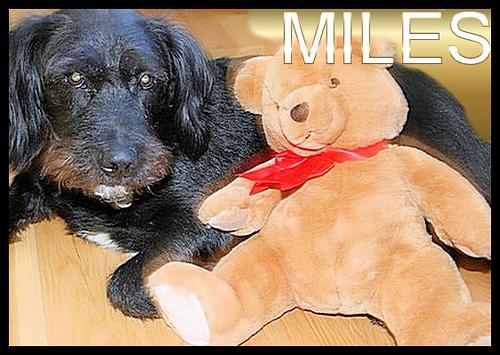What color is the bear's ribbon?
Be succinct. Red. What type of dog is this?
Write a very short answer. Terrier. Is the dog playing with stuffed animals?
Short answer required. Yes. What sport does this dog play?
Be succinct. None. What color are the dogs eyes?
Keep it brief. Brown. Does the dog look happy?
Concise answer only. No. Does the dog want to play?
Quick response, please. No. What do you think the dog's name is?
Keep it brief. Miles. What breed of dog is this?
Short answer required. Schnauzer. Which animal in this picture is a stuffed doll?
Concise answer only. Bear. 